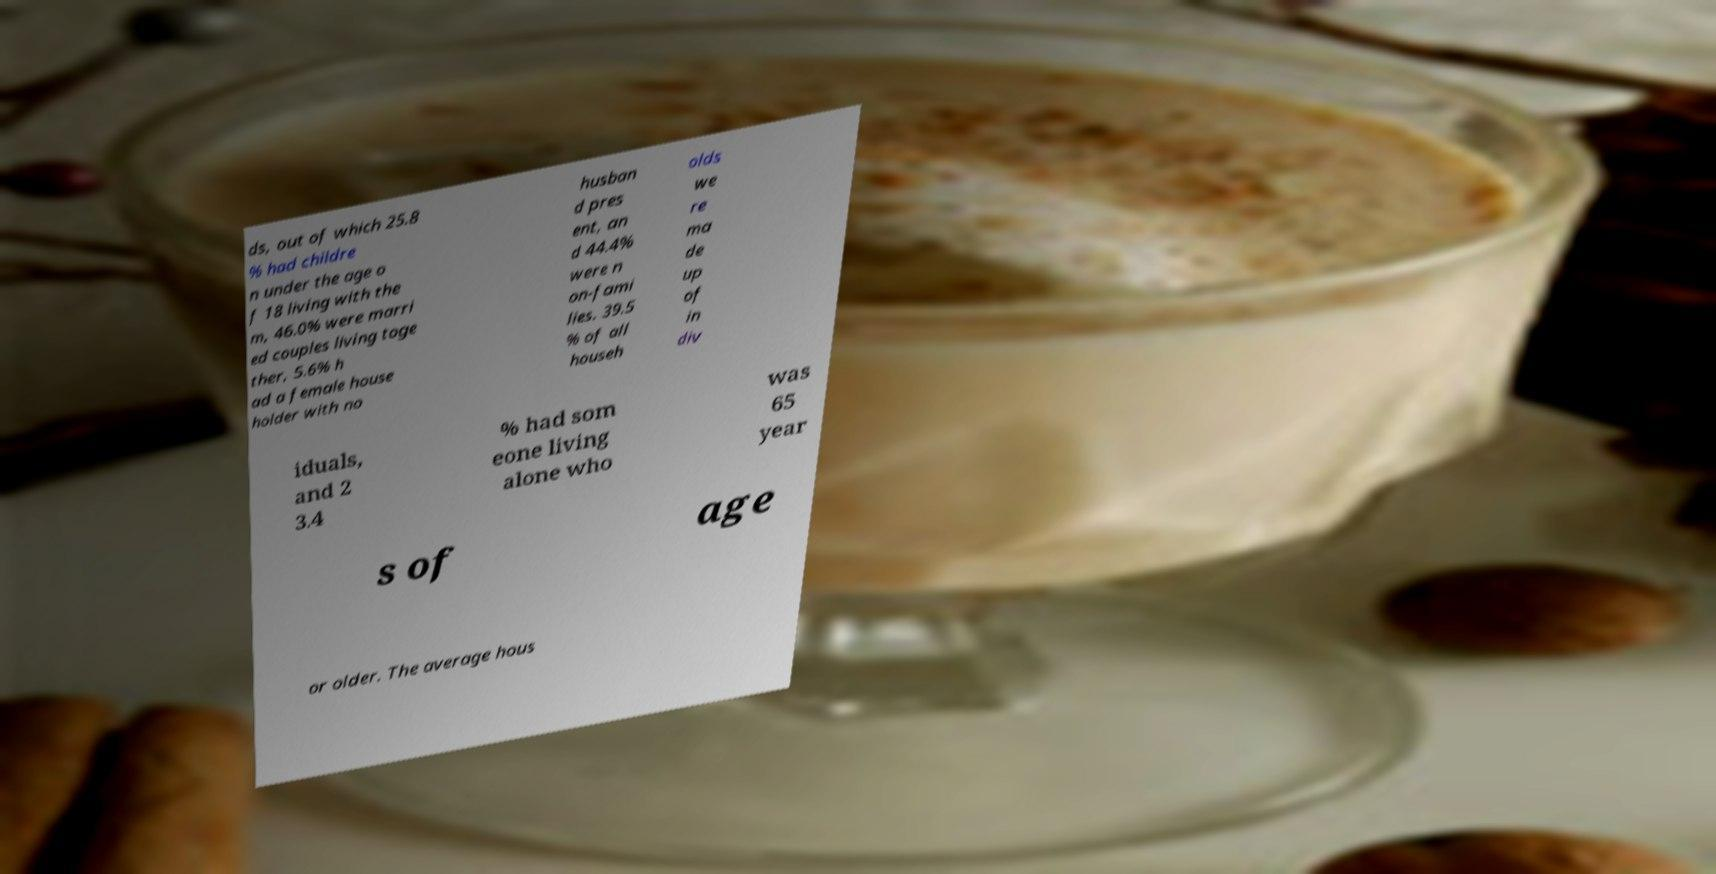Please read and relay the text visible in this image. What does it say? ds, out of which 25.8 % had childre n under the age o f 18 living with the m, 46.0% were marri ed couples living toge ther, 5.6% h ad a female house holder with no husban d pres ent, an d 44.4% were n on-fami lies. 39.5 % of all househ olds we re ma de up of in div iduals, and 2 3.4 % had som eone living alone who was 65 year s of age or older. The average hous 